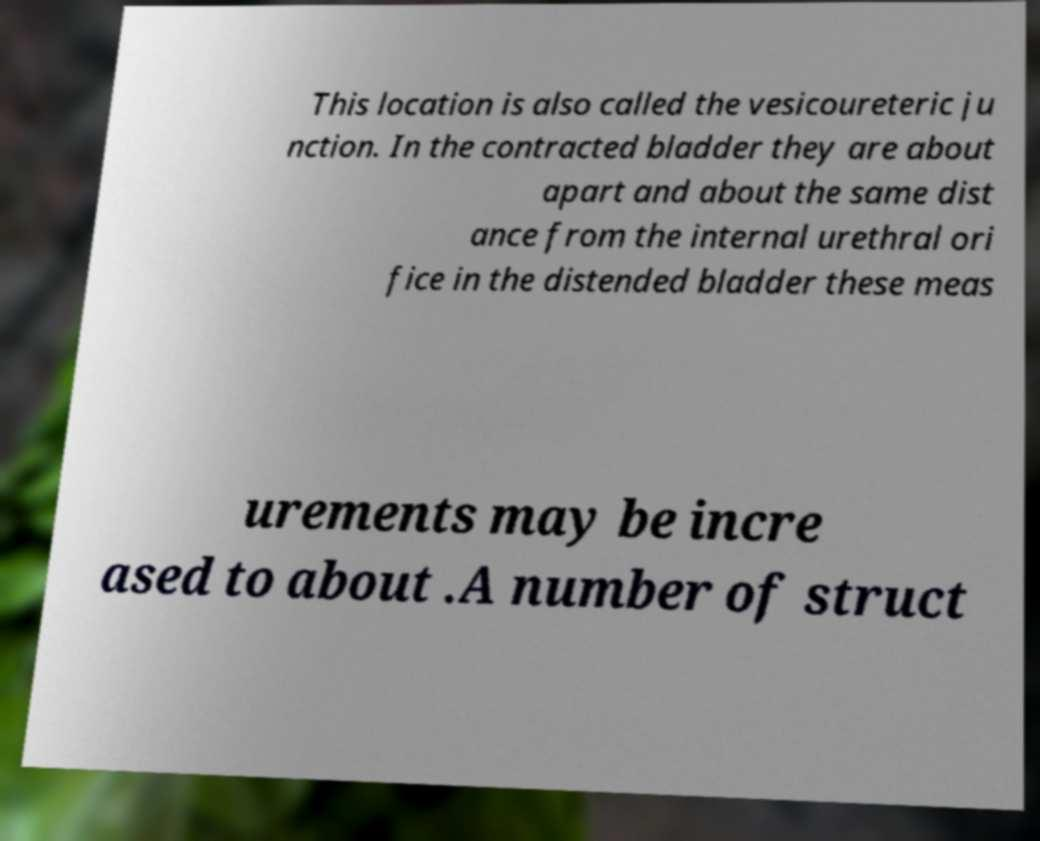Could you assist in decoding the text presented in this image and type it out clearly? This location is also called the vesicoureteric ju nction. In the contracted bladder they are about apart and about the same dist ance from the internal urethral ori fice in the distended bladder these meas urements may be incre ased to about .A number of struct 